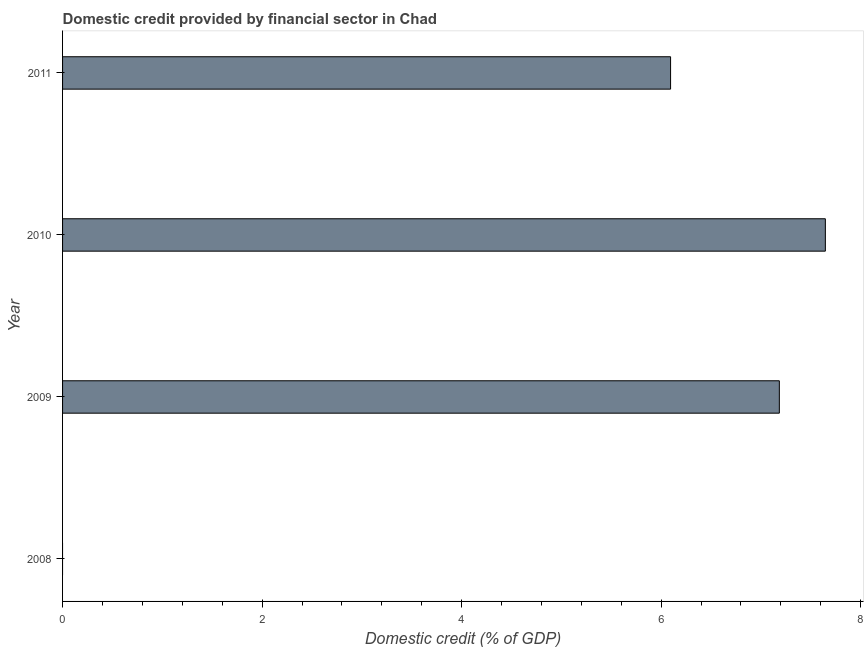Does the graph contain any zero values?
Provide a succinct answer. Yes. Does the graph contain grids?
Keep it short and to the point. No. What is the title of the graph?
Give a very brief answer. Domestic credit provided by financial sector in Chad. What is the label or title of the X-axis?
Your response must be concise. Domestic credit (% of GDP). What is the label or title of the Y-axis?
Ensure brevity in your answer.  Year. What is the domestic credit provided by financial sector in 2011?
Your response must be concise. 6.09. Across all years, what is the maximum domestic credit provided by financial sector?
Your answer should be compact. 7.65. In which year was the domestic credit provided by financial sector maximum?
Make the answer very short. 2010. What is the sum of the domestic credit provided by financial sector?
Offer a terse response. 20.93. What is the difference between the domestic credit provided by financial sector in 2010 and 2011?
Your answer should be compact. 1.55. What is the average domestic credit provided by financial sector per year?
Offer a terse response. 5.23. What is the median domestic credit provided by financial sector?
Provide a succinct answer. 6.64. What is the ratio of the domestic credit provided by financial sector in 2009 to that in 2011?
Make the answer very short. 1.18. What is the difference between the highest and the second highest domestic credit provided by financial sector?
Give a very brief answer. 0.46. What is the difference between the highest and the lowest domestic credit provided by financial sector?
Offer a terse response. 7.65. In how many years, is the domestic credit provided by financial sector greater than the average domestic credit provided by financial sector taken over all years?
Your answer should be compact. 3. How many bars are there?
Make the answer very short. 3. Are all the bars in the graph horizontal?
Make the answer very short. Yes. How many years are there in the graph?
Your answer should be compact. 4. What is the difference between two consecutive major ticks on the X-axis?
Your answer should be compact. 2. What is the Domestic credit (% of GDP) in 2008?
Provide a succinct answer. 0. What is the Domestic credit (% of GDP) in 2009?
Keep it short and to the point. 7.18. What is the Domestic credit (% of GDP) in 2010?
Provide a succinct answer. 7.65. What is the Domestic credit (% of GDP) in 2011?
Ensure brevity in your answer.  6.09. What is the difference between the Domestic credit (% of GDP) in 2009 and 2010?
Provide a short and direct response. -0.46. What is the difference between the Domestic credit (% of GDP) in 2009 and 2011?
Provide a short and direct response. 1.09. What is the difference between the Domestic credit (% of GDP) in 2010 and 2011?
Ensure brevity in your answer.  1.55. What is the ratio of the Domestic credit (% of GDP) in 2009 to that in 2010?
Offer a very short reply. 0.94. What is the ratio of the Domestic credit (% of GDP) in 2009 to that in 2011?
Give a very brief answer. 1.18. What is the ratio of the Domestic credit (% of GDP) in 2010 to that in 2011?
Keep it short and to the point. 1.25. 